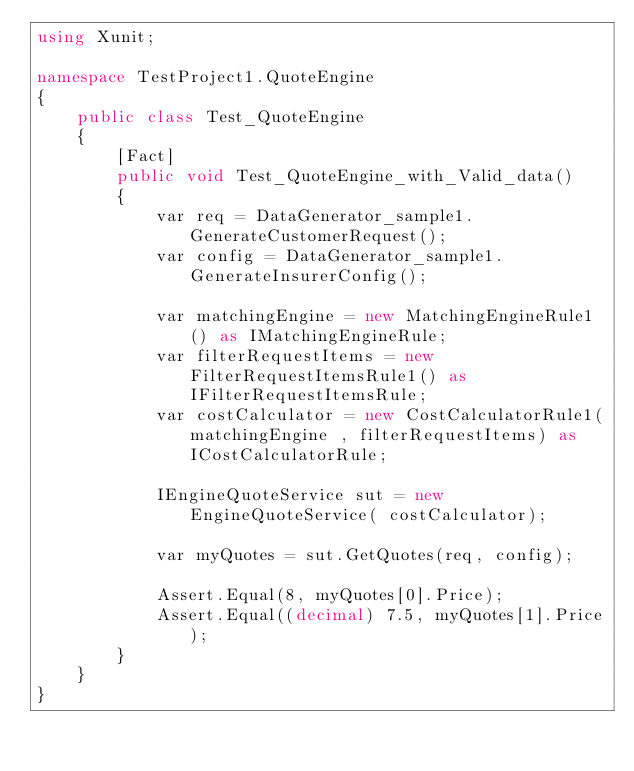Convert code to text. <code><loc_0><loc_0><loc_500><loc_500><_C#_>using Xunit;

namespace TestProject1.QuoteEngine
{
    public class Test_QuoteEngine
    {
        [Fact]
        public void Test_QuoteEngine_with_Valid_data()
        {
            var req = DataGenerator_sample1.GenerateCustomerRequest();
            var config = DataGenerator_sample1.GenerateInsurerConfig();

            var matchingEngine = new MatchingEngineRule1() as IMatchingEngineRule;
            var filterRequestItems = new FilterRequestItemsRule1() as IFilterRequestItemsRule;
            var costCalculator = new CostCalculatorRule1(matchingEngine , filterRequestItems) as ICostCalculatorRule;
            
            IEngineQuoteService sut = new EngineQuoteService( costCalculator);

            var myQuotes = sut.GetQuotes(req, config);

            Assert.Equal(8, myQuotes[0].Price);
            Assert.Equal((decimal) 7.5, myQuotes[1].Price);
        }
    }
}</code> 